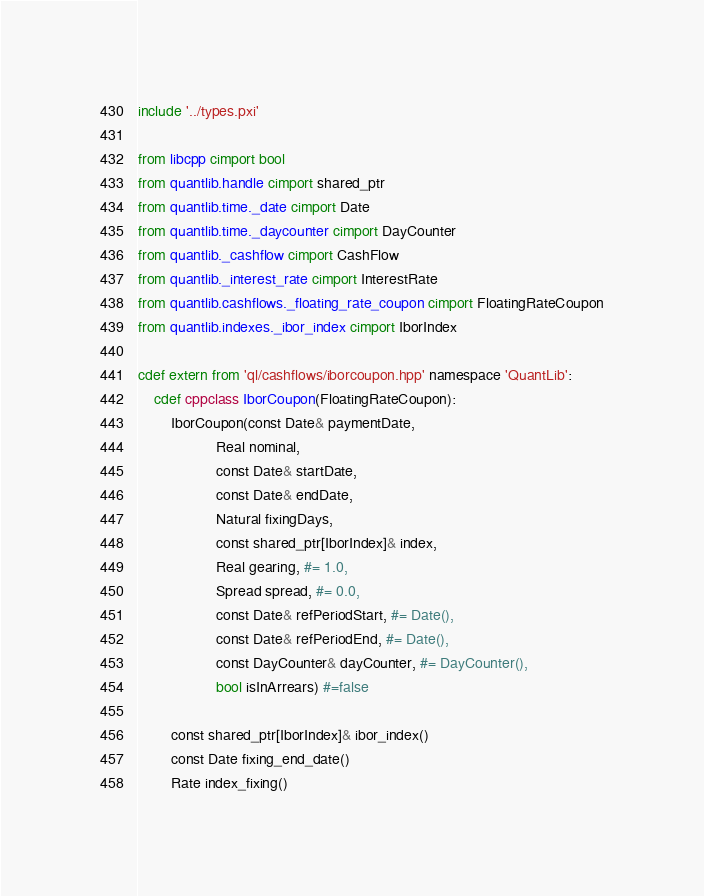<code> <loc_0><loc_0><loc_500><loc_500><_Cython_>include '../types.pxi'

from libcpp cimport bool
from quantlib.handle cimport shared_ptr
from quantlib.time._date cimport Date
from quantlib.time._daycounter cimport DayCounter
from quantlib._cashflow cimport CashFlow
from quantlib._interest_rate cimport InterestRate
from quantlib.cashflows._floating_rate_coupon cimport FloatingRateCoupon
from quantlib.indexes._ibor_index cimport IborIndex

cdef extern from 'ql/cashflows/iborcoupon.hpp' namespace 'QuantLib':
    cdef cppclass IborCoupon(FloatingRateCoupon):
        IborCoupon(const Date& paymentDate,
                   Real nominal,
                   const Date& startDate,
                   const Date& endDate,
                   Natural fixingDays,
                   const shared_ptr[IborIndex]& index,
                   Real gearing, #= 1.0,
                   Spread spread, #= 0.0,
                   const Date& refPeriodStart, #= Date(),
                   const Date& refPeriodEnd, #= Date(),
                   const DayCounter& dayCounter, #= DayCounter(),
                   bool isInArrears) #=false

        const shared_ptr[IborIndex]& ibor_index()
        const Date fixing_end_date()
        Rate index_fixing()
</code> 